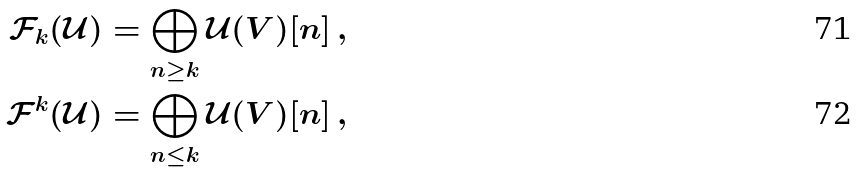Convert formula to latex. <formula><loc_0><loc_0><loc_500><loc_500>\mathcal { F } _ { k } ( \mathcal { U } ) & = \bigoplus _ { n \geq k } \mathcal { U } ( V ) [ n ] \, , \\ \mathcal { F } ^ { k } ( \mathcal { U } ) & = \bigoplus _ { n \leq k } \mathcal { U } ( V ) [ n ] \, ,</formula> 